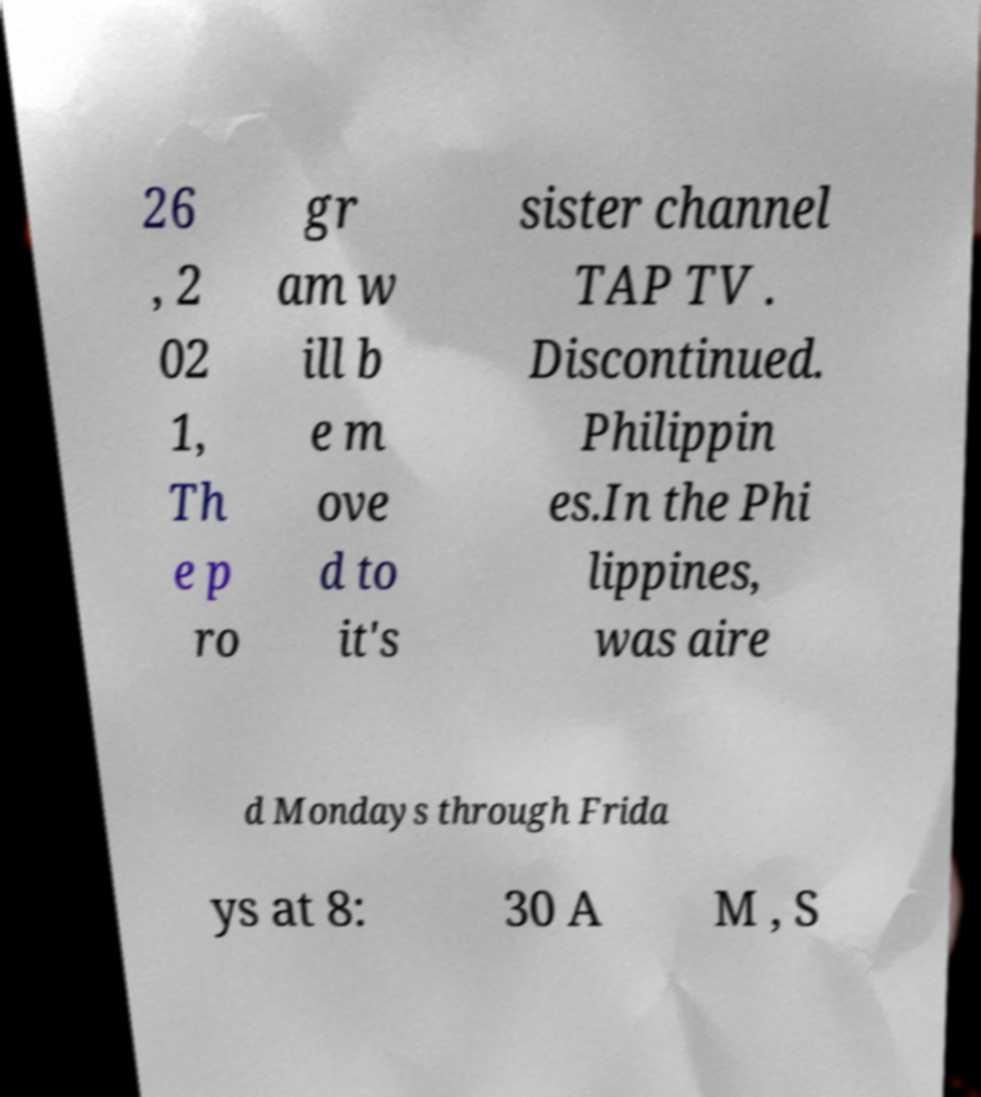There's text embedded in this image that I need extracted. Can you transcribe it verbatim? 26 , 2 02 1, Th e p ro gr am w ill b e m ove d to it's sister channel TAP TV . Discontinued. Philippin es.In the Phi lippines, was aire d Mondays through Frida ys at 8: 30 A M , S 